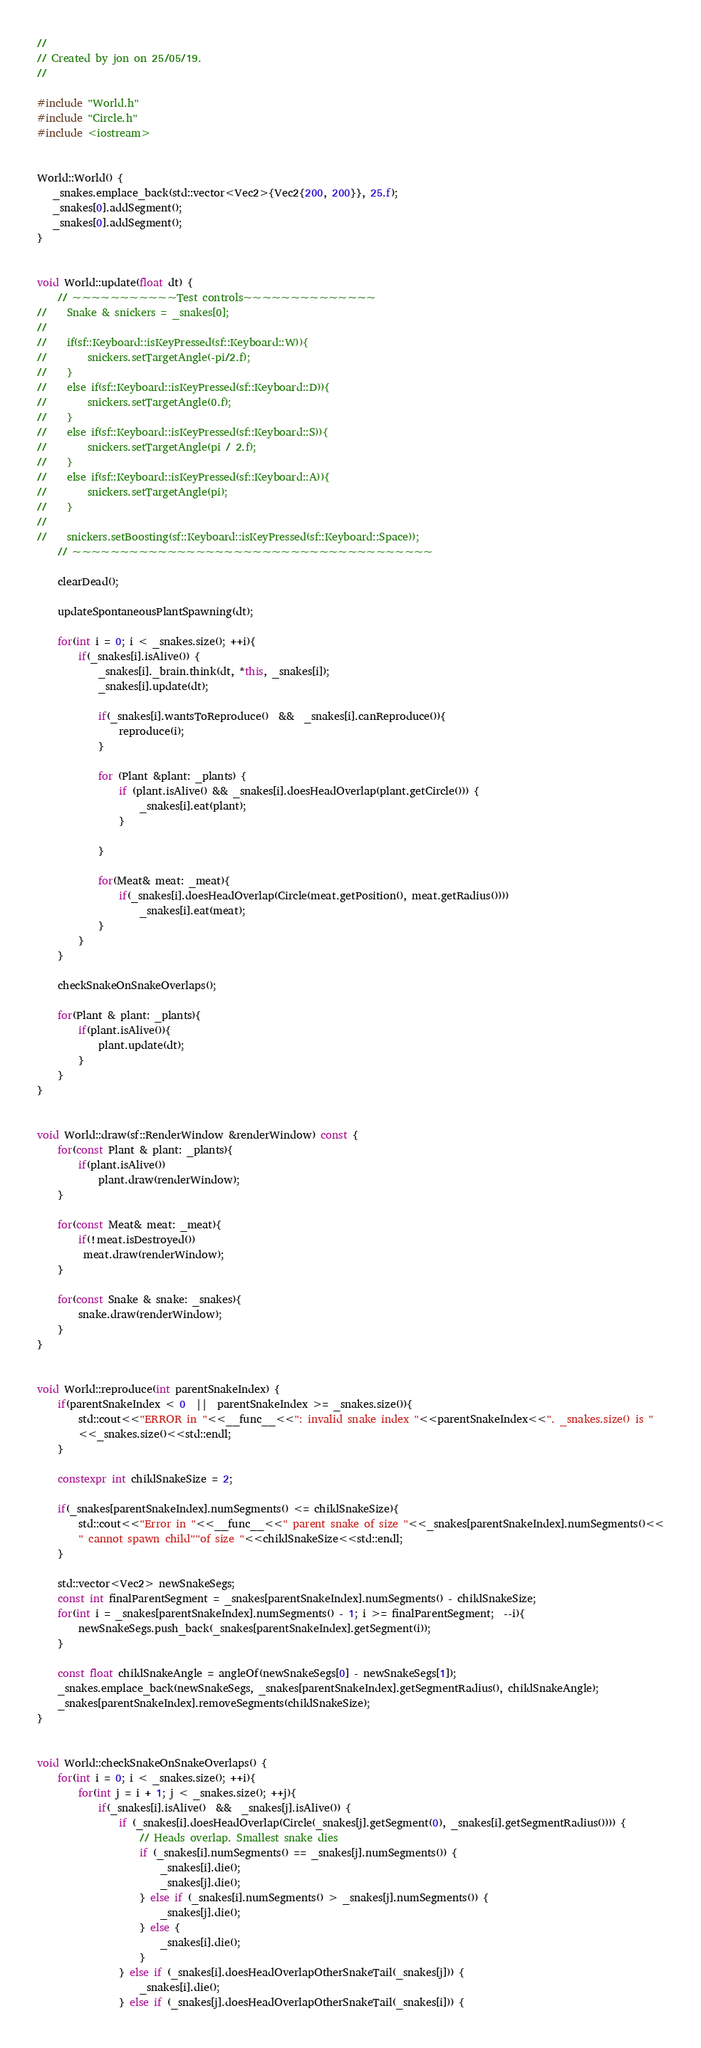<code> <loc_0><loc_0><loc_500><loc_500><_C++_>//
// Created by jon on 25/05/19.
//

#include "World.h"
#include "Circle.h"
#include <iostream>


World::World() {
   _snakes.emplace_back(std::vector<Vec2>{Vec2{200, 200}}, 25.f);
   _snakes[0].addSegment();
   _snakes[0].addSegment();
}


void World::update(float dt) {
    // ~~~~~~~~~~~Test controls~~~~~~~~~~~~~~
//    Snake & snickers = _snakes[0];
//
//    if(sf::Keyboard::isKeyPressed(sf::Keyboard::W)){
//        snickers.setTargetAngle(-pi/2.f);
//    }
//    else if(sf::Keyboard::isKeyPressed(sf::Keyboard::D)){
//        snickers.setTargetAngle(0.f);
//    }
//    else if(sf::Keyboard::isKeyPressed(sf::Keyboard::S)){
//        snickers.setTargetAngle(pi / 2.f);
//    }
//    else if(sf::Keyboard::isKeyPressed(sf::Keyboard::A)){
//        snickers.setTargetAngle(pi);
//    }
//
//    snickers.setBoosting(sf::Keyboard::isKeyPressed(sf::Keyboard::Space));
    // ~~~~~~~~~~~~~~~~~~~~~~~~~~~~~~~~~~~~~~

    clearDead();

    updateSpontaneousPlantSpawning(dt);

    for(int i = 0; i < _snakes.size(); ++i){
        if(_snakes[i].isAlive()) {
            _snakes[i]._brain.think(dt, *this, _snakes[i]);
            _snakes[i].update(dt);

            if(_snakes[i].wantsToReproduce()  &&  _snakes[i].canReproduce()){
                reproduce(i);
            }

            for (Plant &plant: _plants) {
                if (plant.isAlive() && _snakes[i].doesHeadOverlap(plant.getCircle())) {
                    _snakes[i].eat(plant);
                }

            }

            for(Meat& meat: _meat){
                if(_snakes[i].doesHeadOverlap(Circle(meat.getPosition(), meat.getRadius())))
                    _snakes[i].eat(meat);
            }
        }
    }

    checkSnakeOnSnakeOverlaps();

    for(Plant & plant: _plants){
        if(plant.isAlive()){
            plant.update(dt);
        }
    }
}


void World::draw(sf::RenderWindow &renderWindow) const {
    for(const Plant & plant: _plants){
        if(plant.isAlive())
            plant.draw(renderWindow);
    }

    for(const Meat& meat: _meat){
        if(!meat.isDestroyed())
         meat.draw(renderWindow);
    }

    for(const Snake & snake: _snakes){
        snake.draw(renderWindow);
    }
}


void World::reproduce(int parentSnakeIndex) {
    if(parentSnakeIndex < 0  ||  parentSnakeIndex >= _snakes.size()){
        std::cout<<"ERROR in "<<__func__<<": invalid snake index "<<parentSnakeIndex<<". _snakes.size() is "
        <<_snakes.size()<<std::endl;
    }

    constexpr int childSnakeSize = 2;

    if(_snakes[parentSnakeIndex].numSegments() <= childSnakeSize){
        std::cout<<"Error in "<<__func__<<" parent snake of size "<<_snakes[parentSnakeIndex].numSegments()<<
        " cannot spawn child""of size "<<childSnakeSize<<std::endl;
    }

    std::vector<Vec2> newSnakeSegs;
    const int finalParentSegment = _snakes[parentSnakeIndex].numSegments() - childSnakeSize;
    for(int i = _snakes[parentSnakeIndex].numSegments() - 1; i >= finalParentSegment;  --i){
        newSnakeSegs.push_back(_snakes[parentSnakeIndex].getSegment(i));
    }

    const float childSnakeAngle = angleOf(newSnakeSegs[0] - newSnakeSegs[1]);
    _snakes.emplace_back(newSnakeSegs, _snakes[parentSnakeIndex].getSegmentRadius(), childSnakeAngle);
    _snakes[parentSnakeIndex].removeSegments(childSnakeSize);
}


void World::checkSnakeOnSnakeOverlaps() {
    for(int i = 0; i < _snakes.size(); ++i){
        for(int j = i + 1; j < _snakes.size(); ++j){
            if(_snakes[i].isAlive()  &&  _snakes[j].isAlive()) {
                if (_snakes[i].doesHeadOverlap(Circle(_snakes[j].getSegment(0), _snakes[i].getSegmentRadius()))) {
                    // Heads overlap. Smallest snake dies
                    if (_snakes[i].numSegments() == _snakes[j].numSegments()) {
                        _snakes[i].die();
                        _snakes[j].die();
                    } else if (_snakes[i].numSegments() > _snakes[j].numSegments()) {
                        _snakes[j].die();
                    } else {
                        _snakes[i].die();
                    }
                } else if (_snakes[i].doesHeadOverlapOtherSnakeTail(_snakes[j])) {
                    _snakes[i].die();
                } else if (_snakes[j].doesHeadOverlapOtherSnakeTail(_snakes[i])) {</code> 